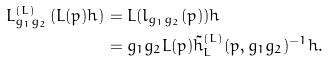<formula> <loc_0><loc_0><loc_500><loc_500>L ^ { ( L ) } _ { g _ { 1 } g _ { 2 } } \left ( L ( p ) h \right ) & = L ( l _ { g _ { 1 } g _ { 2 } } ( p ) ) h \\ & = g _ { 1 } g _ { 2 } L ( p ) \tilde { h } ^ { ( L ) } _ { L } ( p , g _ { 1 } g _ { 2 } ) ^ { - 1 } h .</formula> 